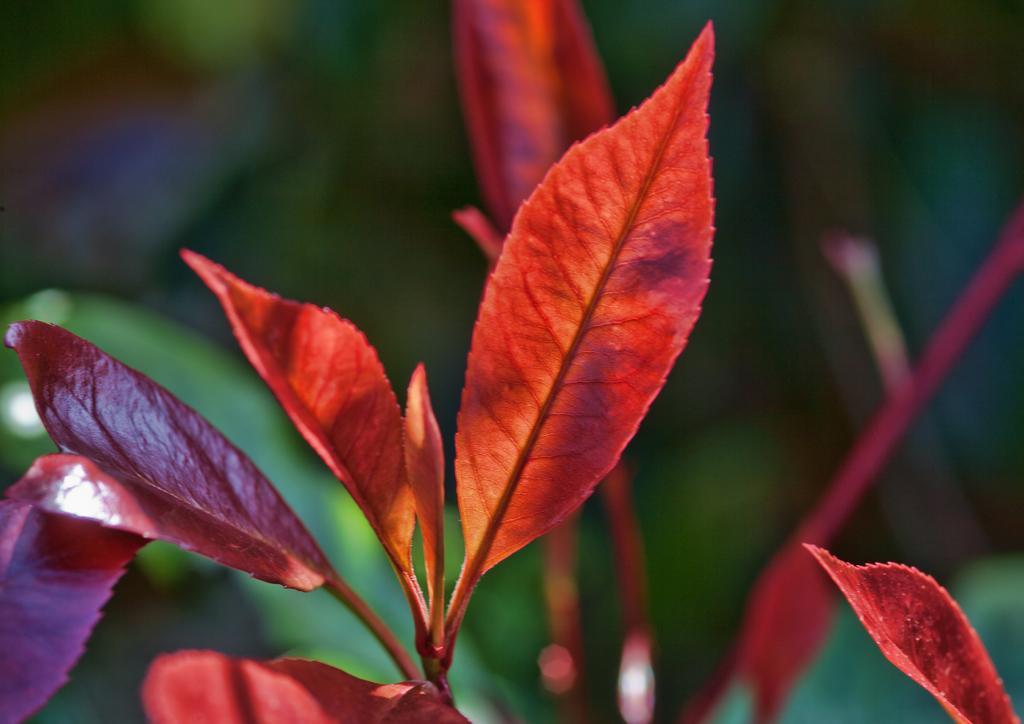Describe this image in one or two sentences. In this picture we can see there are colored leaves and behind the leaves there is blurred background. 